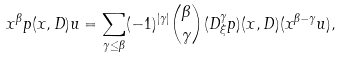Convert formula to latex. <formula><loc_0><loc_0><loc_500><loc_500>x ^ { \beta } p ( x , D ) u = \sum _ { \gamma \leq \beta } ( - 1 ) ^ { | \gamma | } \binom { \beta } { \gamma } ( D ^ { \gamma } _ { \xi } p ) ( x , D ) ( x ^ { \beta - \gamma } u ) ,</formula> 